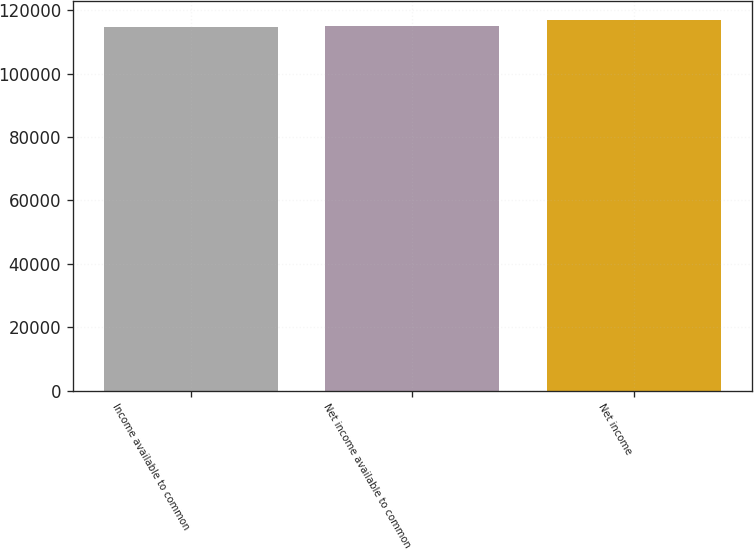<chart> <loc_0><loc_0><loc_500><loc_500><bar_chart><fcel>Income available to common<fcel>Net income available to common<fcel>Net income<nl><fcel>114721<fcel>114957<fcel>117077<nl></chart> 